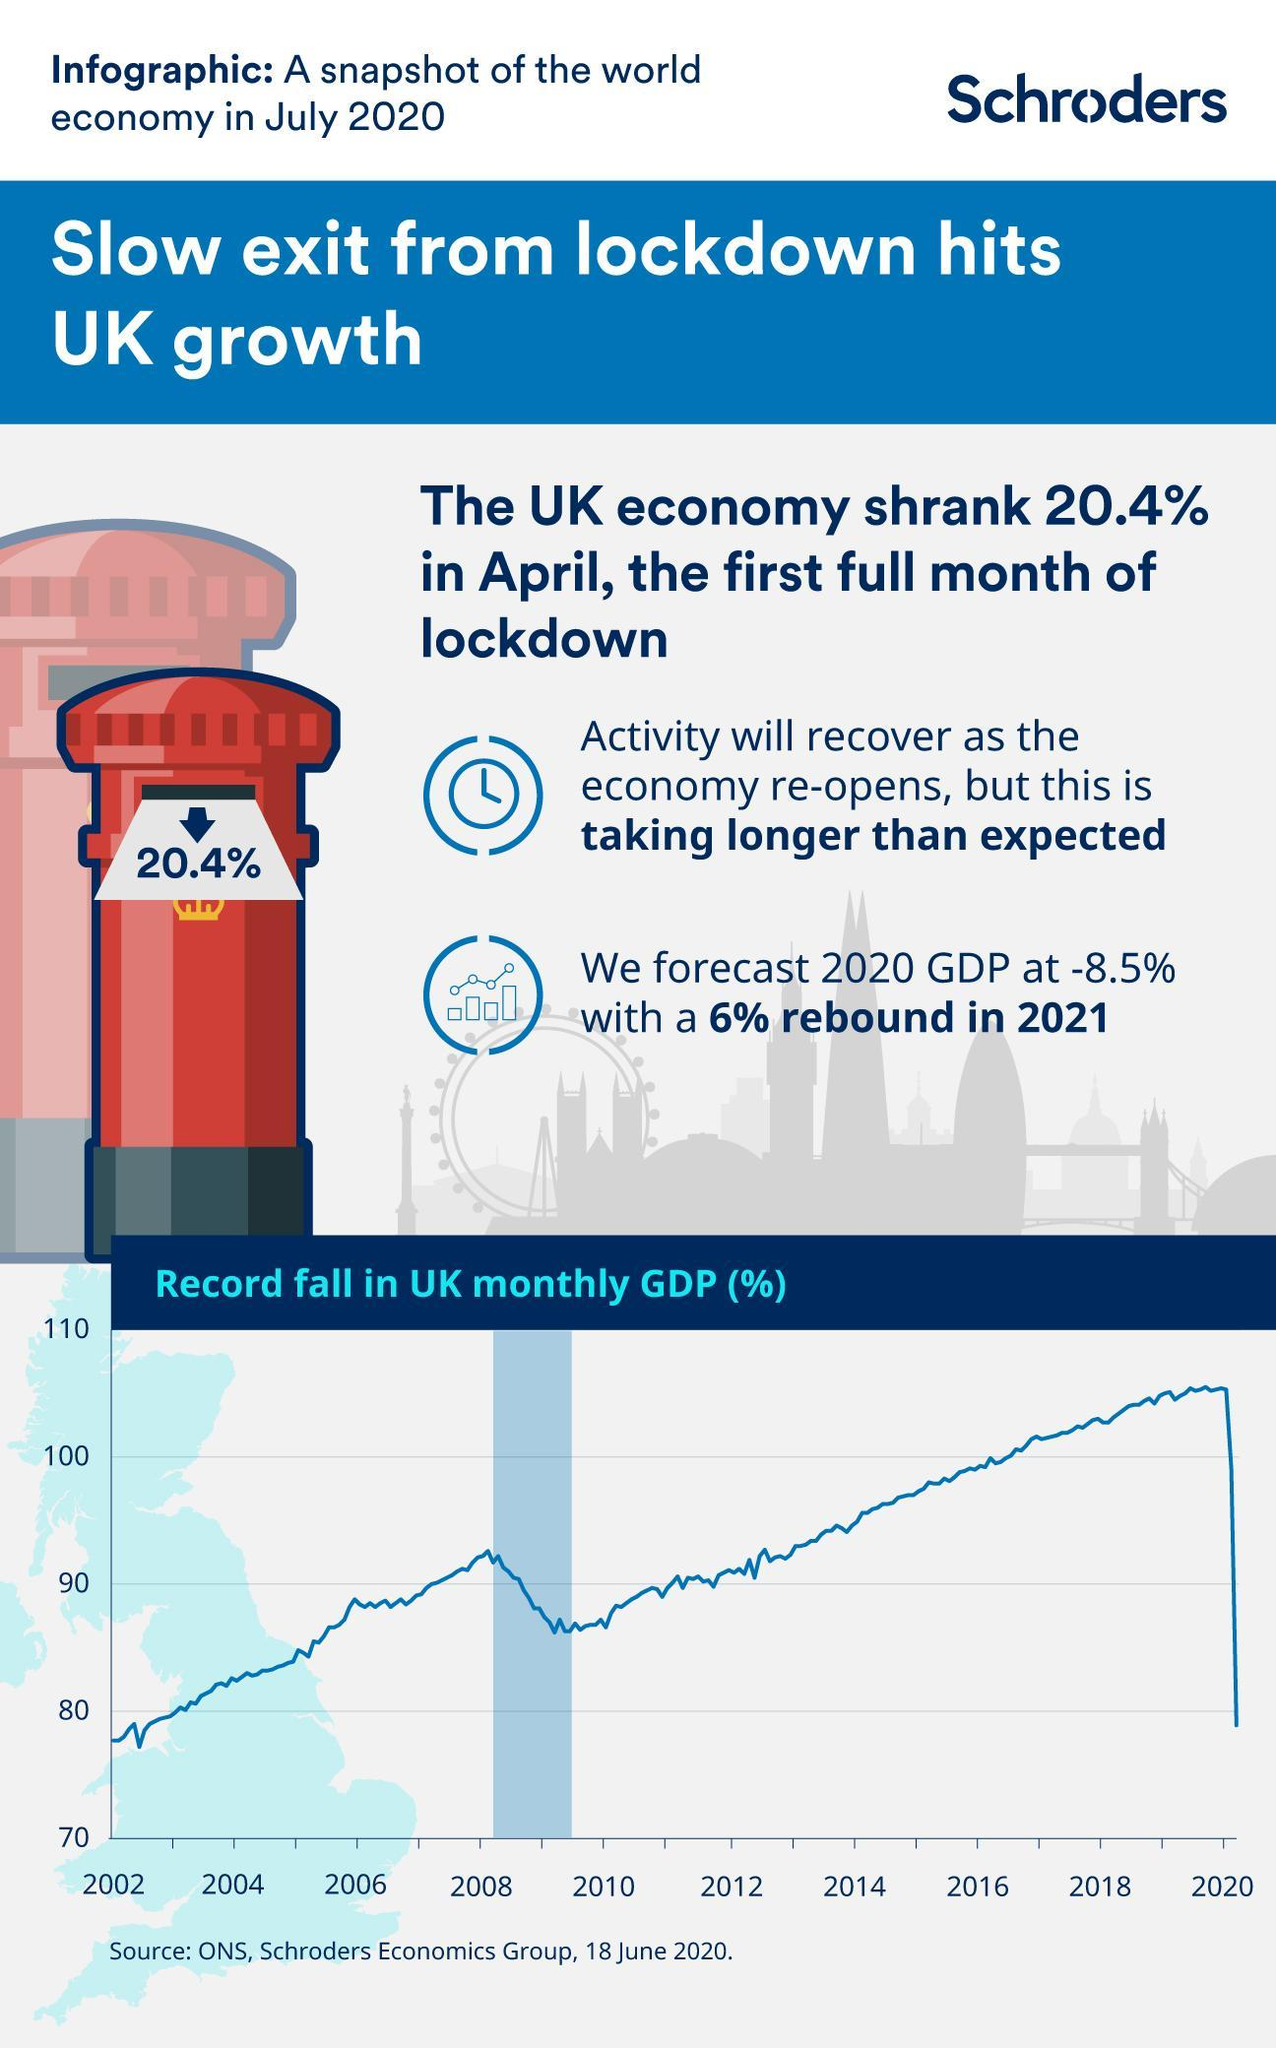What is the inverse percentage of UK economy shrank?
Answer the question with a short phrase. 79.6 